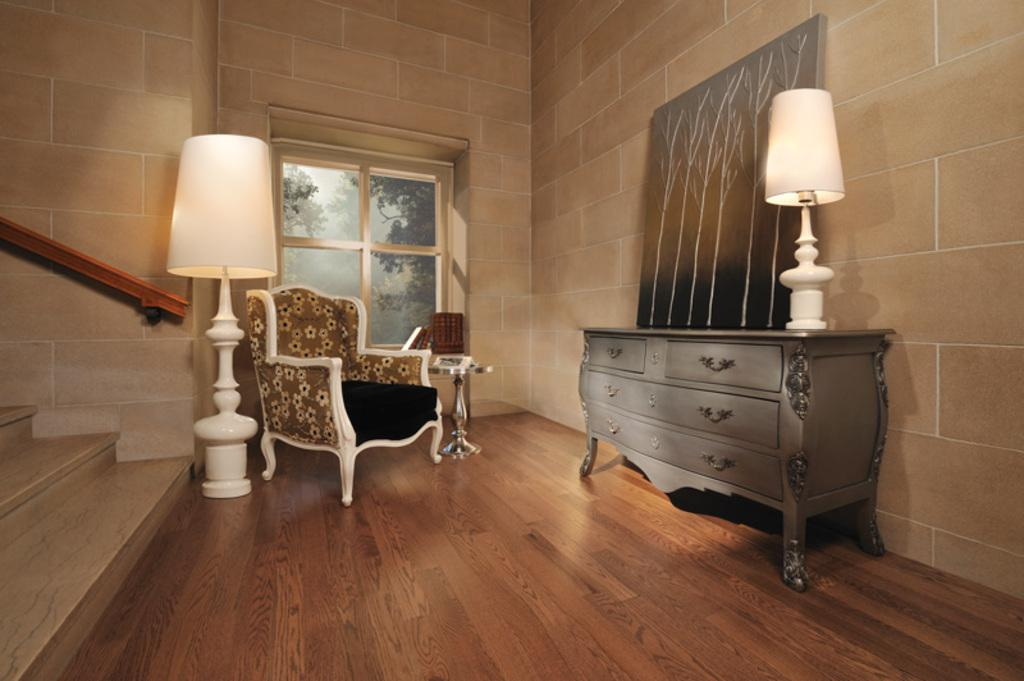What type of architectural feature is present in the image? There are stairs in the image. How many lights can be seen in the image? There are two lights in the image. What is located on a table in the image? There is a photo frame on a table in the image. What type of furniture is visible in the image? There is a chair visible in the image. What is your dad doing in the image? There is no person, including a dad, present in the image. 